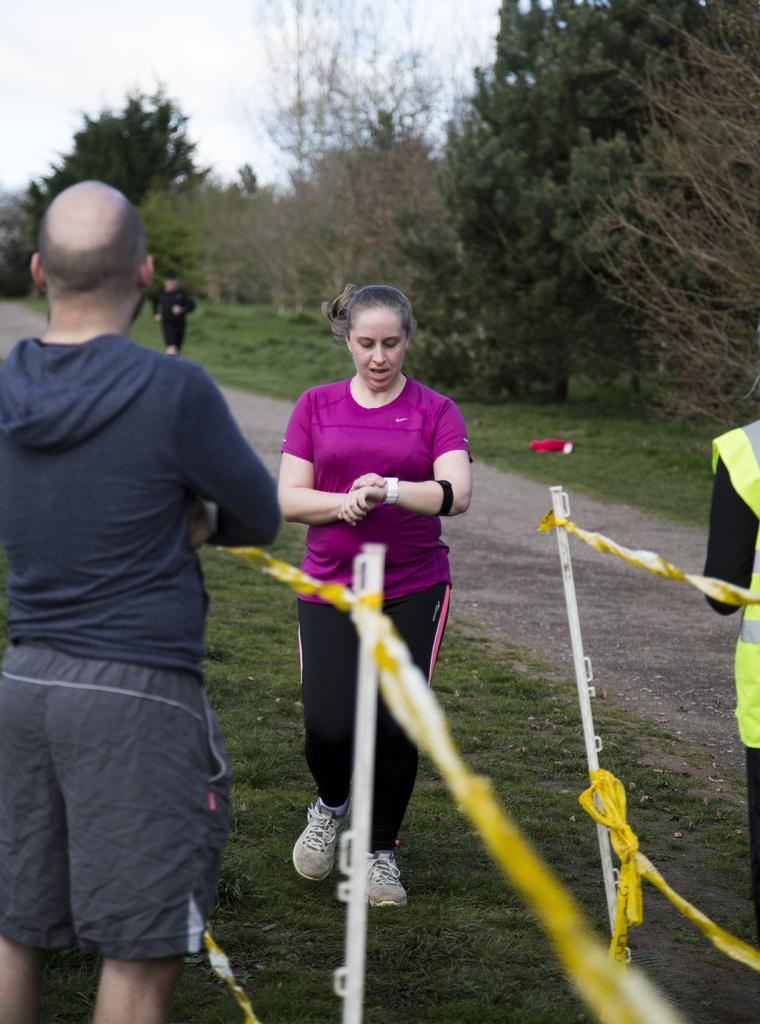What is the surface on which the persons are standing in the image? The persons are standing on the grass in the image. What objects are present that might be used for a specific activity? Ropes and poles are visible in the image, which might be used for an activity like a game or performance. Can you describe the background of the image? In the background of the image, there is a person, a path, trees, and the sky visible. What type of baseball game is being played in the image? There is no baseball game present in the image; it features persons standing on grass with ropes and poles. How does the wind affect the curtain in the image? There is no curtain present in the image, so it is not possible to determine how the wind might affect it. 